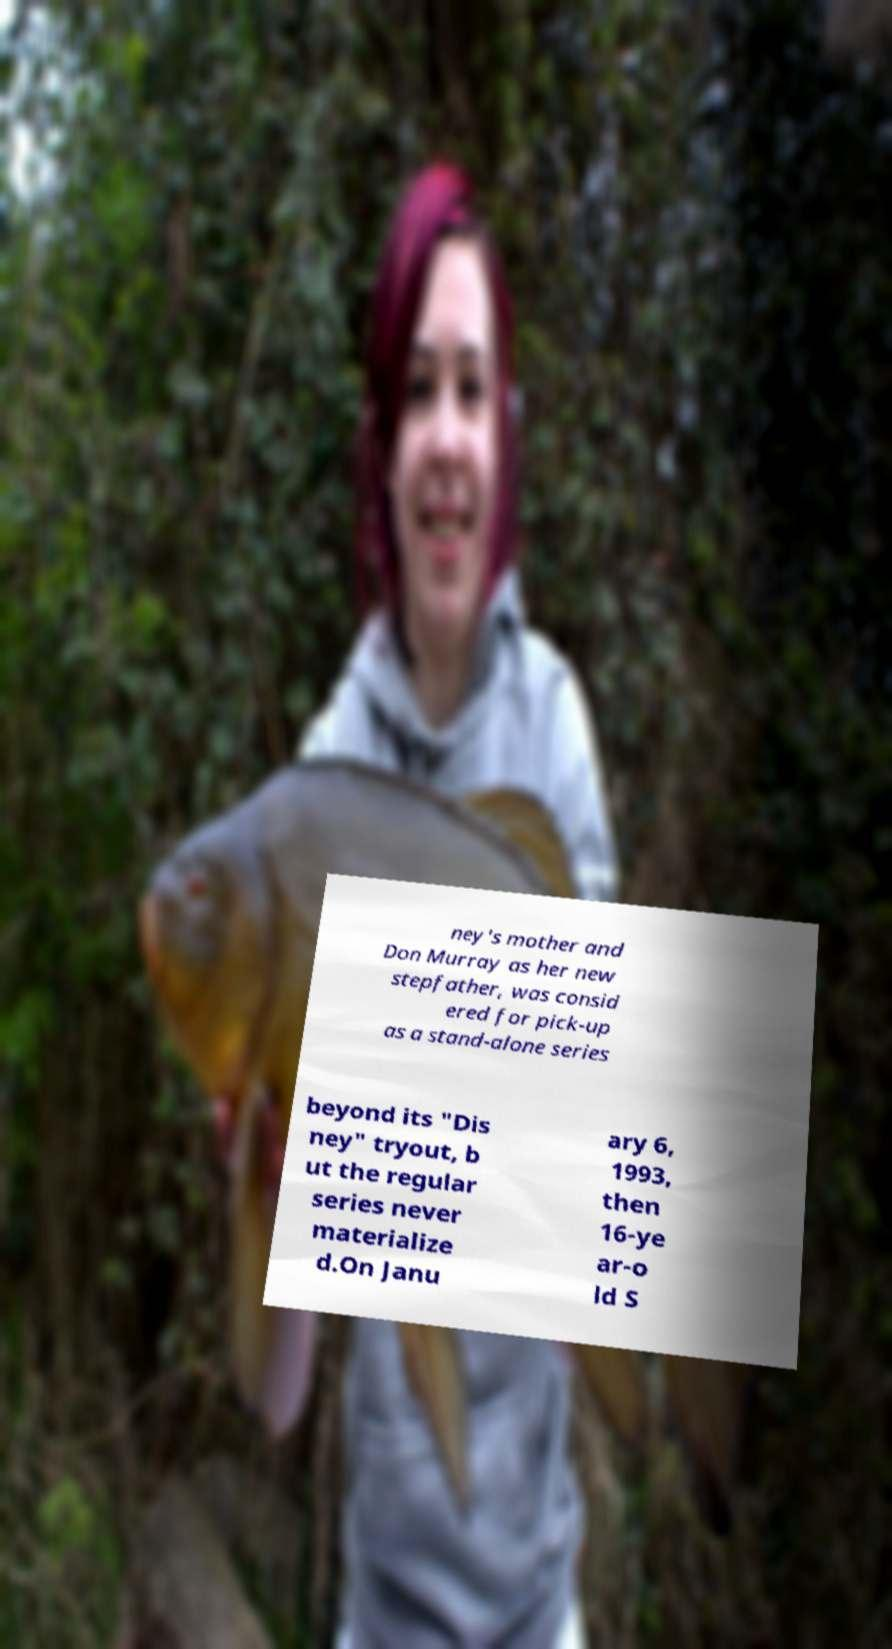Can you accurately transcribe the text from the provided image for me? ney's mother and Don Murray as her new stepfather, was consid ered for pick-up as a stand-alone series beyond its "Dis ney" tryout, b ut the regular series never materialize d.On Janu ary 6, 1993, then 16-ye ar-o ld S 